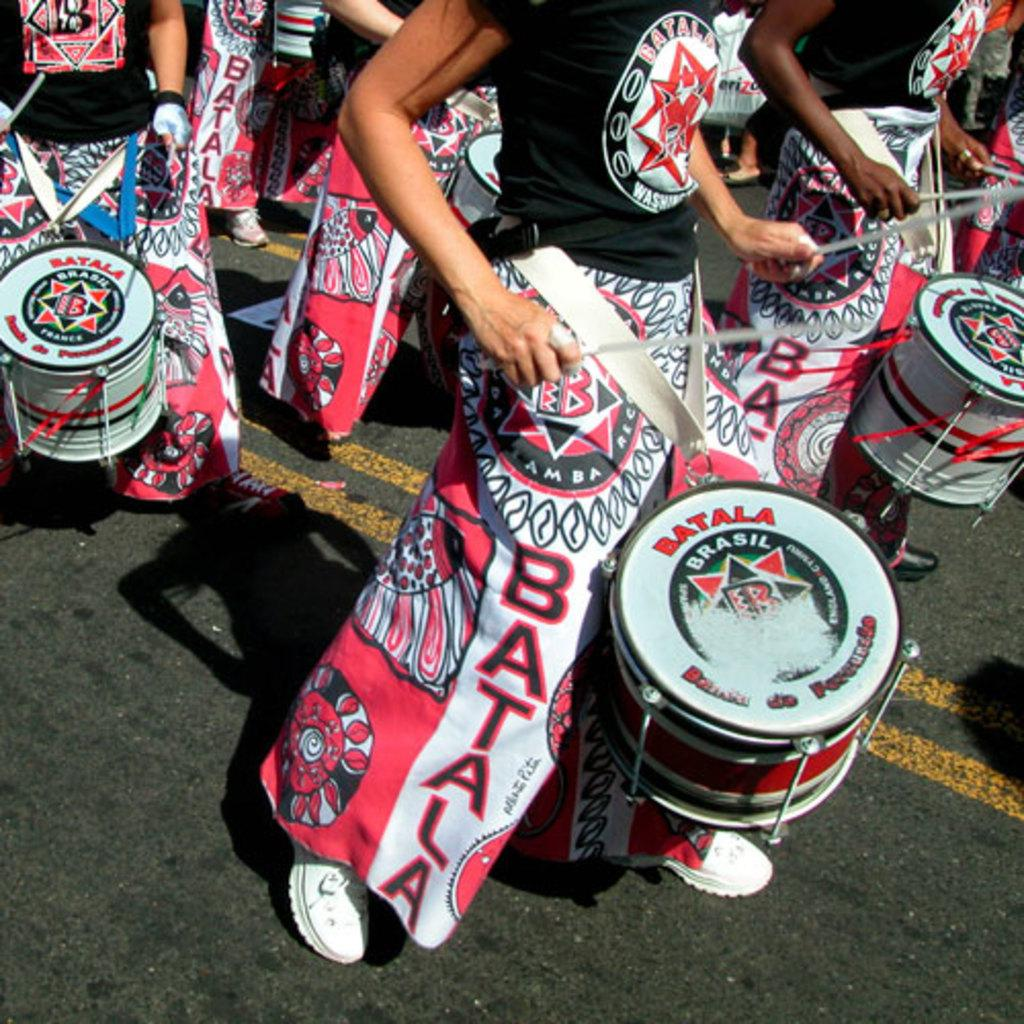<image>
Create a compact narrative representing the image presented. An event is taking place in Brasil and people are playing drums. 